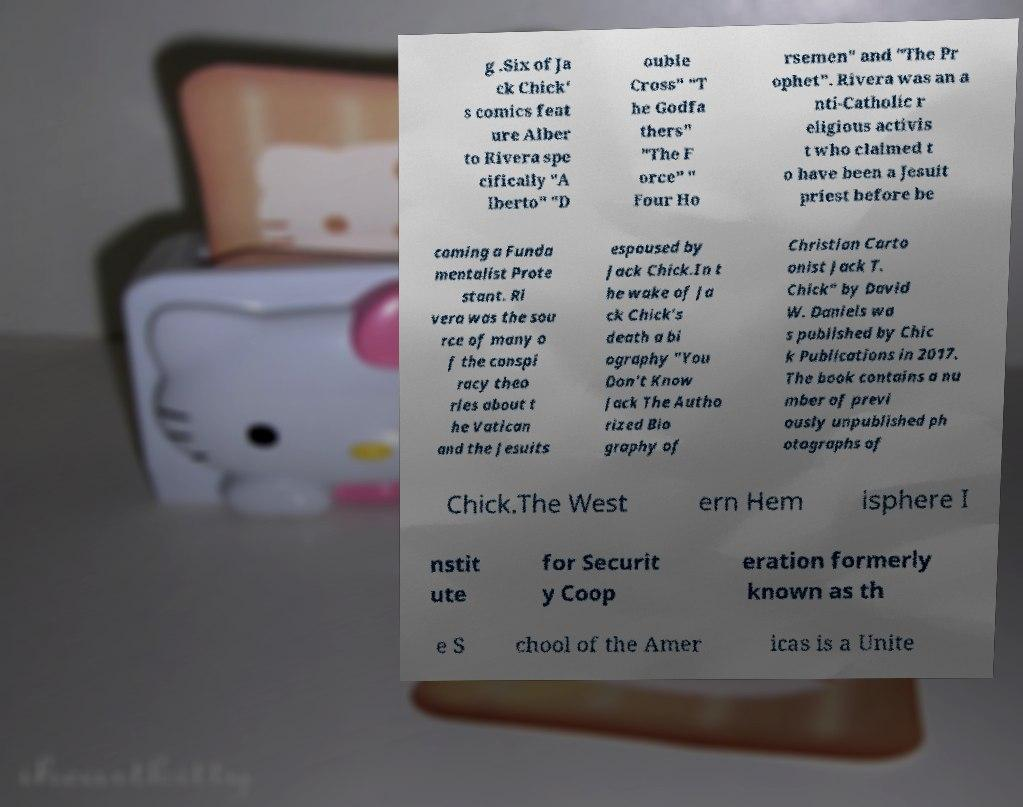There's text embedded in this image that I need extracted. Can you transcribe it verbatim? g .Six of Ja ck Chick' s comics feat ure Alber to Rivera spe cifically "A lberto" "D ouble Cross" "T he Godfa thers" "The F orce" " Four Ho rsemen" and "The Pr ophet". Rivera was an a nti-Catholic r eligious activis t who claimed t o have been a Jesuit priest before be coming a Funda mentalist Prote stant. Ri vera was the sou rce of many o f the conspi racy theo ries about t he Vatican and the Jesuits espoused by Jack Chick.In t he wake of Ja ck Chick's death a bi ography "You Don't Know Jack The Autho rized Bio graphy of Christian Carto onist Jack T. Chick" by David W. Daniels wa s published by Chic k Publications in 2017. The book contains a nu mber of previ ously unpublished ph otographs of Chick.The West ern Hem isphere I nstit ute for Securit y Coop eration formerly known as th e S chool of the Amer icas is a Unite 